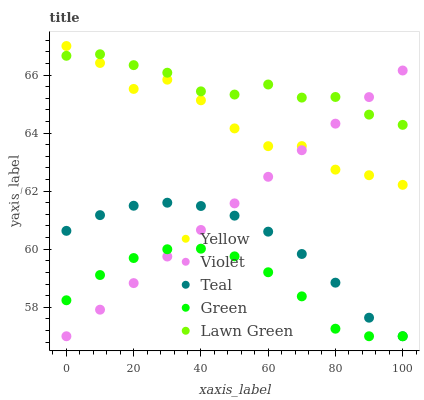Does Green have the minimum area under the curve?
Answer yes or no. Yes. Does Lawn Green have the maximum area under the curve?
Answer yes or no. Yes. Does Teal have the minimum area under the curve?
Answer yes or no. No. Does Teal have the maximum area under the curve?
Answer yes or no. No. Is Violet the smoothest?
Answer yes or no. Yes. Is Yellow the roughest?
Answer yes or no. Yes. Is Green the smoothest?
Answer yes or no. No. Is Green the roughest?
Answer yes or no. No. Does Green have the lowest value?
Answer yes or no. Yes. Does Yellow have the lowest value?
Answer yes or no. No. Does Yellow have the highest value?
Answer yes or no. Yes. Does Teal have the highest value?
Answer yes or no. No. Is Green less than Yellow?
Answer yes or no. Yes. Is Lawn Green greater than Teal?
Answer yes or no. Yes. Does Lawn Green intersect Yellow?
Answer yes or no. Yes. Is Lawn Green less than Yellow?
Answer yes or no. No. Is Lawn Green greater than Yellow?
Answer yes or no. No. Does Green intersect Yellow?
Answer yes or no. No. 